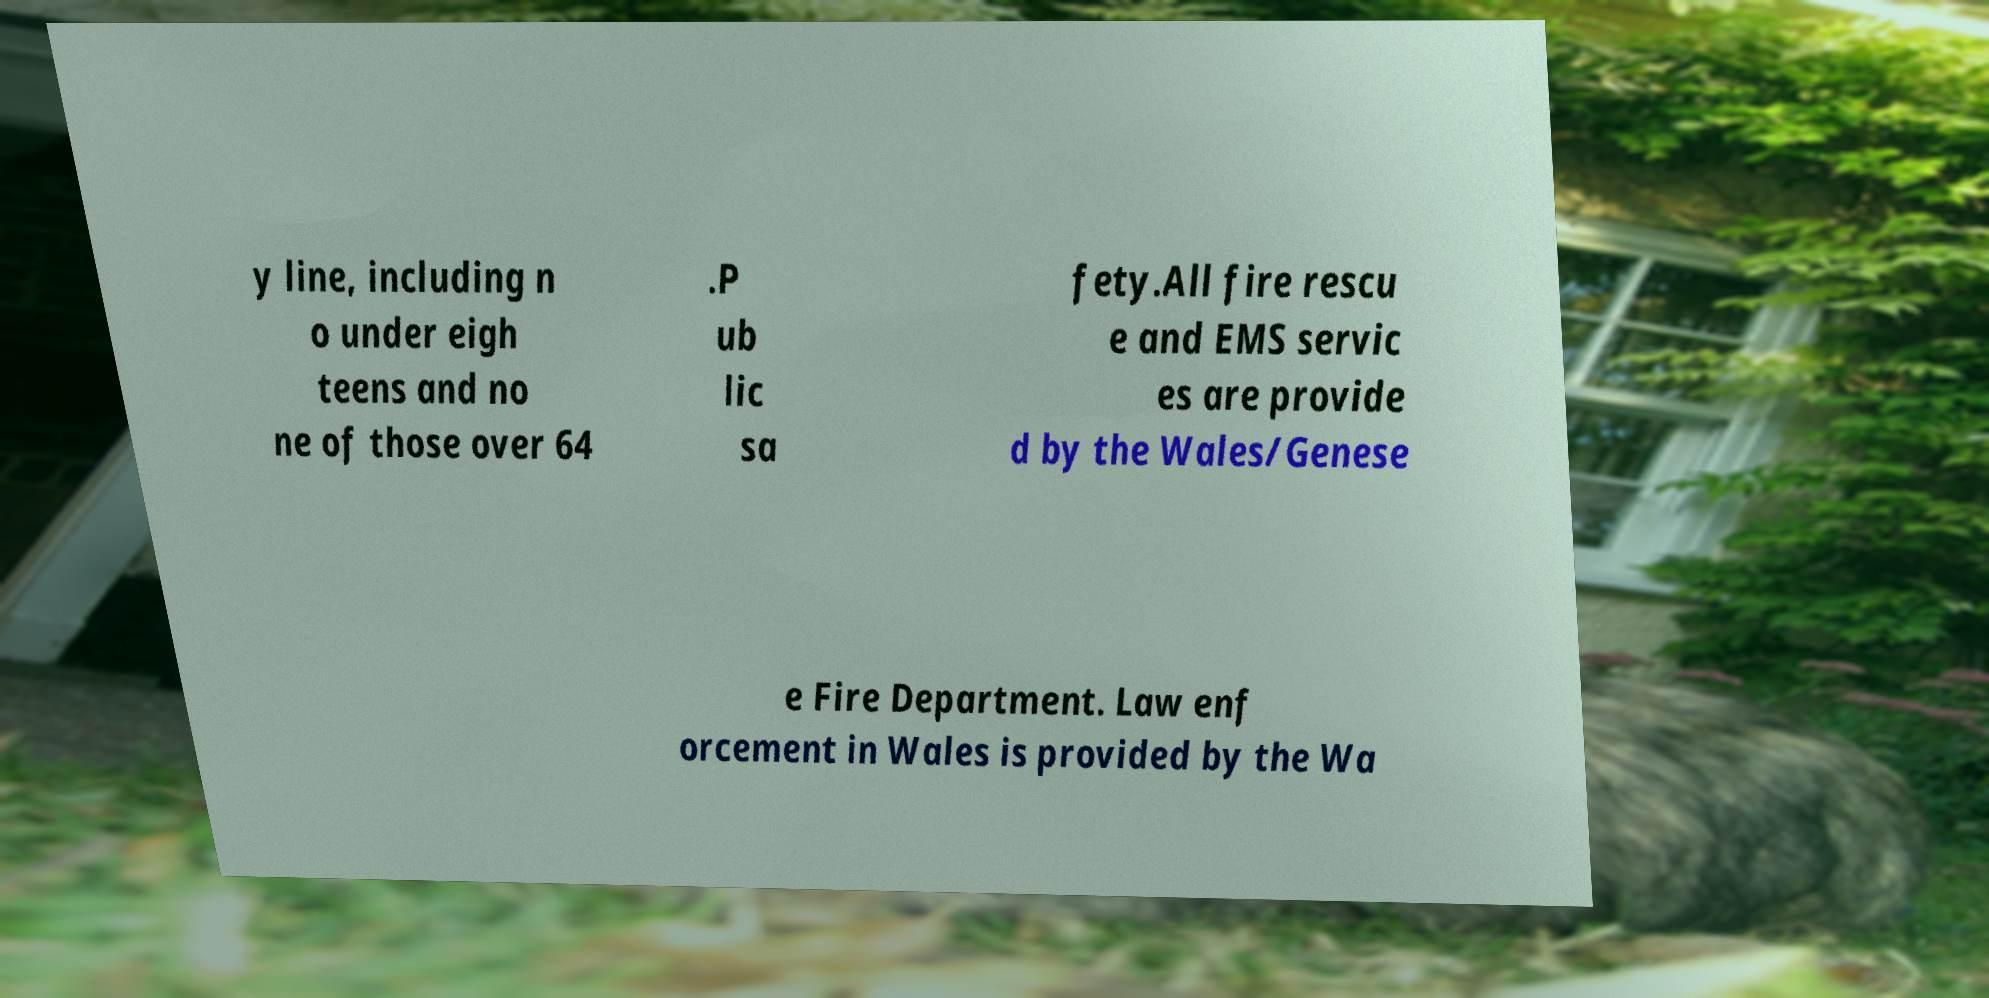Please identify and transcribe the text found in this image. y line, including n o under eigh teens and no ne of those over 64 .P ub lic sa fety.All fire rescu e and EMS servic es are provide d by the Wales/Genese e Fire Department. Law enf orcement in Wales is provided by the Wa 